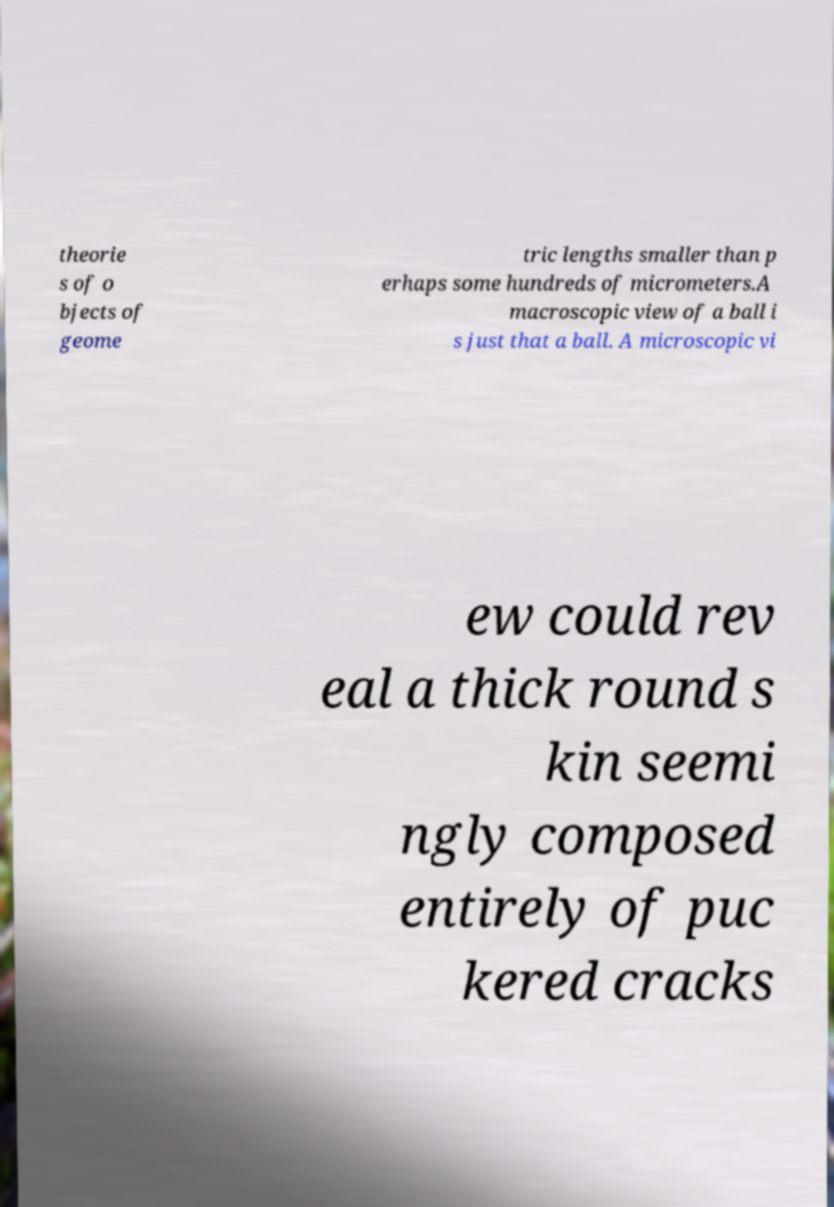Could you extract and type out the text from this image? theorie s of o bjects of geome tric lengths smaller than p erhaps some hundreds of micrometers.A macroscopic view of a ball i s just that a ball. A microscopic vi ew could rev eal a thick round s kin seemi ngly composed entirely of puc kered cracks 